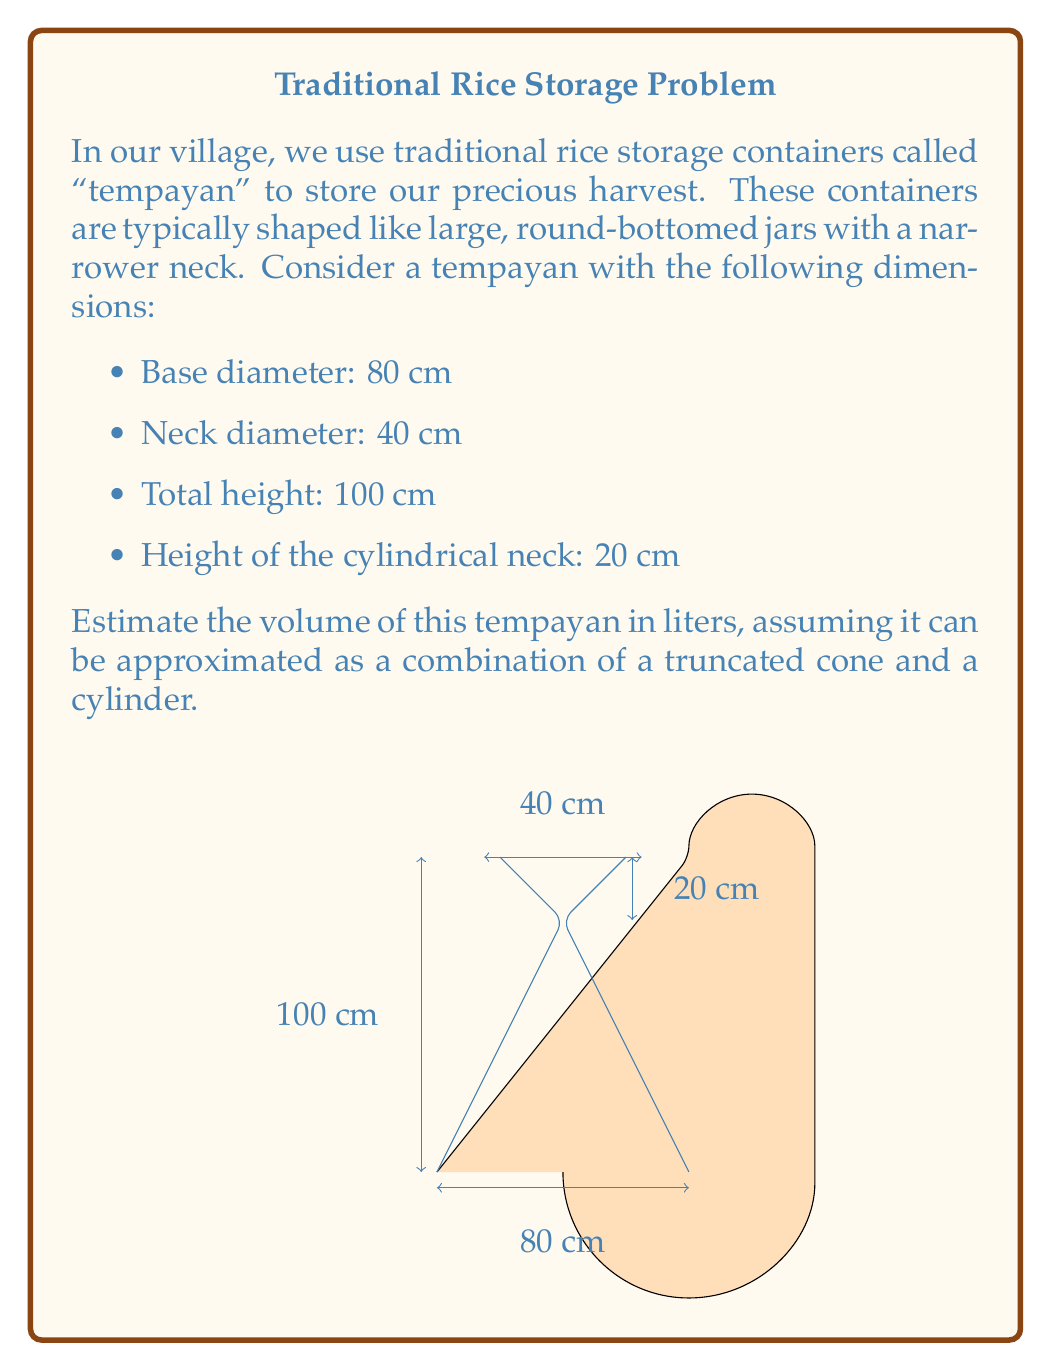Provide a solution to this math problem. To estimate the volume of the tempayan, we'll divide it into two parts: a truncated cone for the main body and a cylinder for the neck. Let's solve this step-by-step:

1. Volume of the truncated cone (main body):
   The formula for the volume of a truncated cone is:
   $$V_c = \frac{1}{3}\pi h (R^2 + r^2 + Rr)$$
   where $h$ is the height, $R$ is the radius of the base, and $r$ is the radius of the top.

   $h = 100 - 20 = 80$ cm (total height minus neck height)
   $R = 40$ cm (base radius)
   $r = 20$ cm (neck radius)

   $$V_c = \frac{1}{3}\pi \cdot 80 \cdot (40^2 + 20^2 + 40 \cdot 20)$$
   $$V_c = \frac{1}{3}\pi \cdot 80 \cdot (1600 + 400 + 800)$$
   $$V_c = \frac{1}{3}\pi \cdot 80 \cdot 2800$$
   $$V_c = 74666.67$ cm³

2. Volume of the cylindrical neck:
   The formula for the volume of a cylinder is:
   $$V_n = \pi r^2 h$$

   $r = 20$ cm (neck radius)
   $h = 20$ cm (neck height)

   $$V_n = \pi \cdot 20^2 \cdot 20$$
   $$V_n = 25132.74$ cm³

3. Total volume:
   $$V_{total} = V_c + V_n = 74666.67 + 25132.74 = 99799.41$ cm³

4. Convert to liters:
   $1$ liter = $1000$ cm³
   $$V_{liters} = 99799.41 \div 1000 \approx 99.80$ liters

Therefore, the estimated volume of the tempayan is approximately 99.80 liters.
Answer: 99.80 liters 